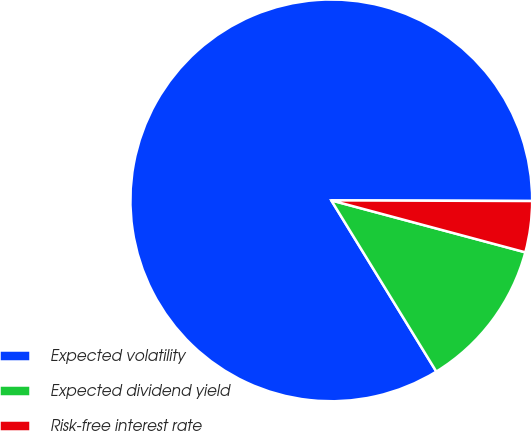Convert chart. <chart><loc_0><loc_0><loc_500><loc_500><pie_chart><fcel>Expected volatility<fcel>Expected dividend yield<fcel>Risk-free interest rate<nl><fcel>83.81%<fcel>12.08%<fcel>4.11%<nl></chart> 